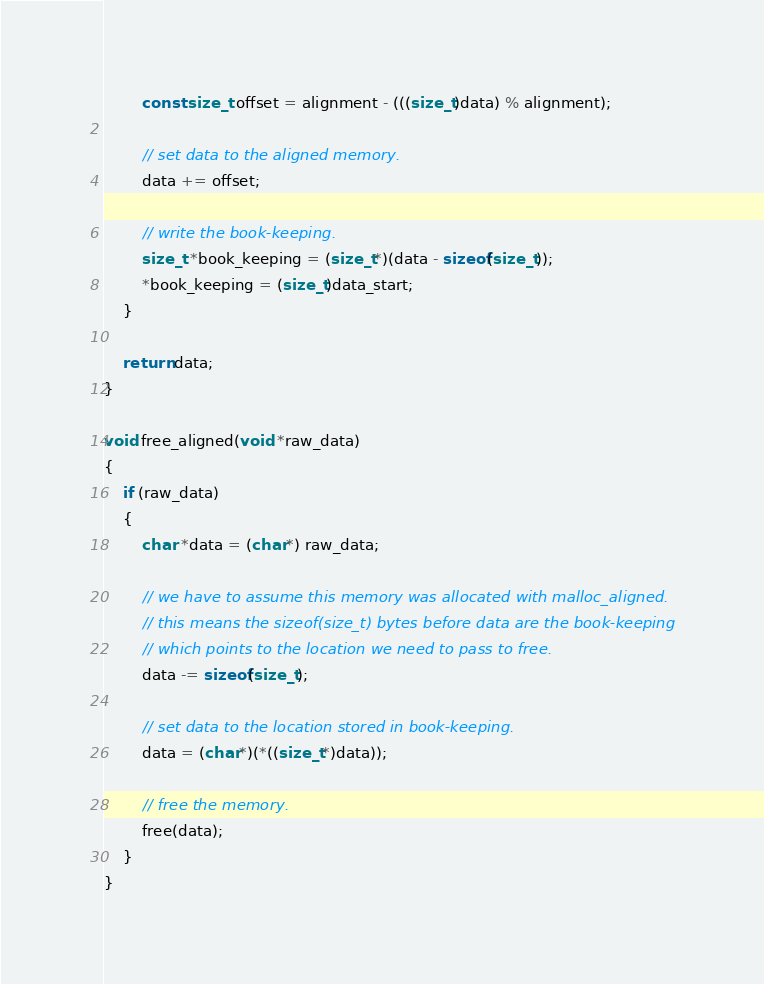Convert code to text. <code><loc_0><loc_0><loc_500><loc_500><_C_>        const size_t offset = alignment - (((size_t)data) % alignment);

        // set data to the aligned memory.
        data += offset;

        // write the book-keeping.
        size_t *book_keeping = (size_t*)(data - sizeof(size_t));
        *book_keeping = (size_t)data_start;
    }

    return data;
}

void free_aligned(void *raw_data)
{
    if (raw_data)
    {
        char *data = (char*) raw_data;

        // we have to assume this memory was allocated with malloc_aligned.
        // this means the sizeof(size_t) bytes before data are the book-keeping
        // which points to the location we need to pass to free.
        data -= sizeof(size_t);

        // set data to the location stored in book-keeping.
        data = (char*)(*((size_t*)data));

        // free the memory.
        free(data);
    }
}
</code> 